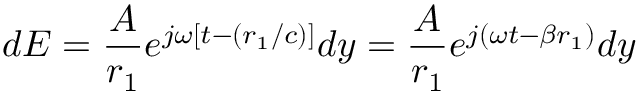Convert formula to latex. <formula><loc_0><loc_0><loc_500><loc_500>d E = { \frac { A } { r _ { 1 } } } e ^ { j \omega [ t - ( r _ { 1 } / c ) ] } d y = { \frac { A } { r _ { 1 } } } e ^ { j ( \omega t - \beta r _ { 1 } ) } d y</formula> 